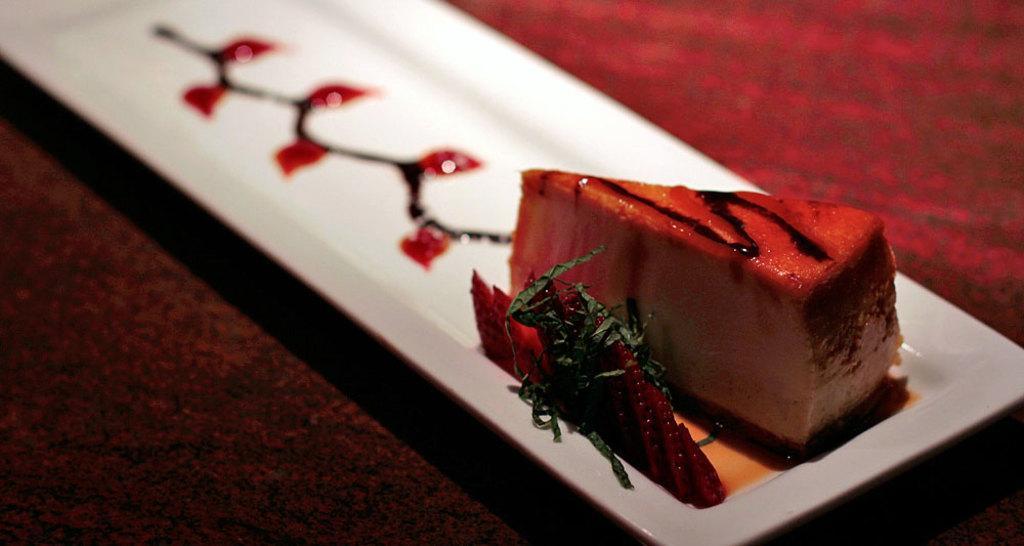In one or two sentences, can you explain what this image depicts? In this picture I can see food in the tray and looks like a table in the background. 